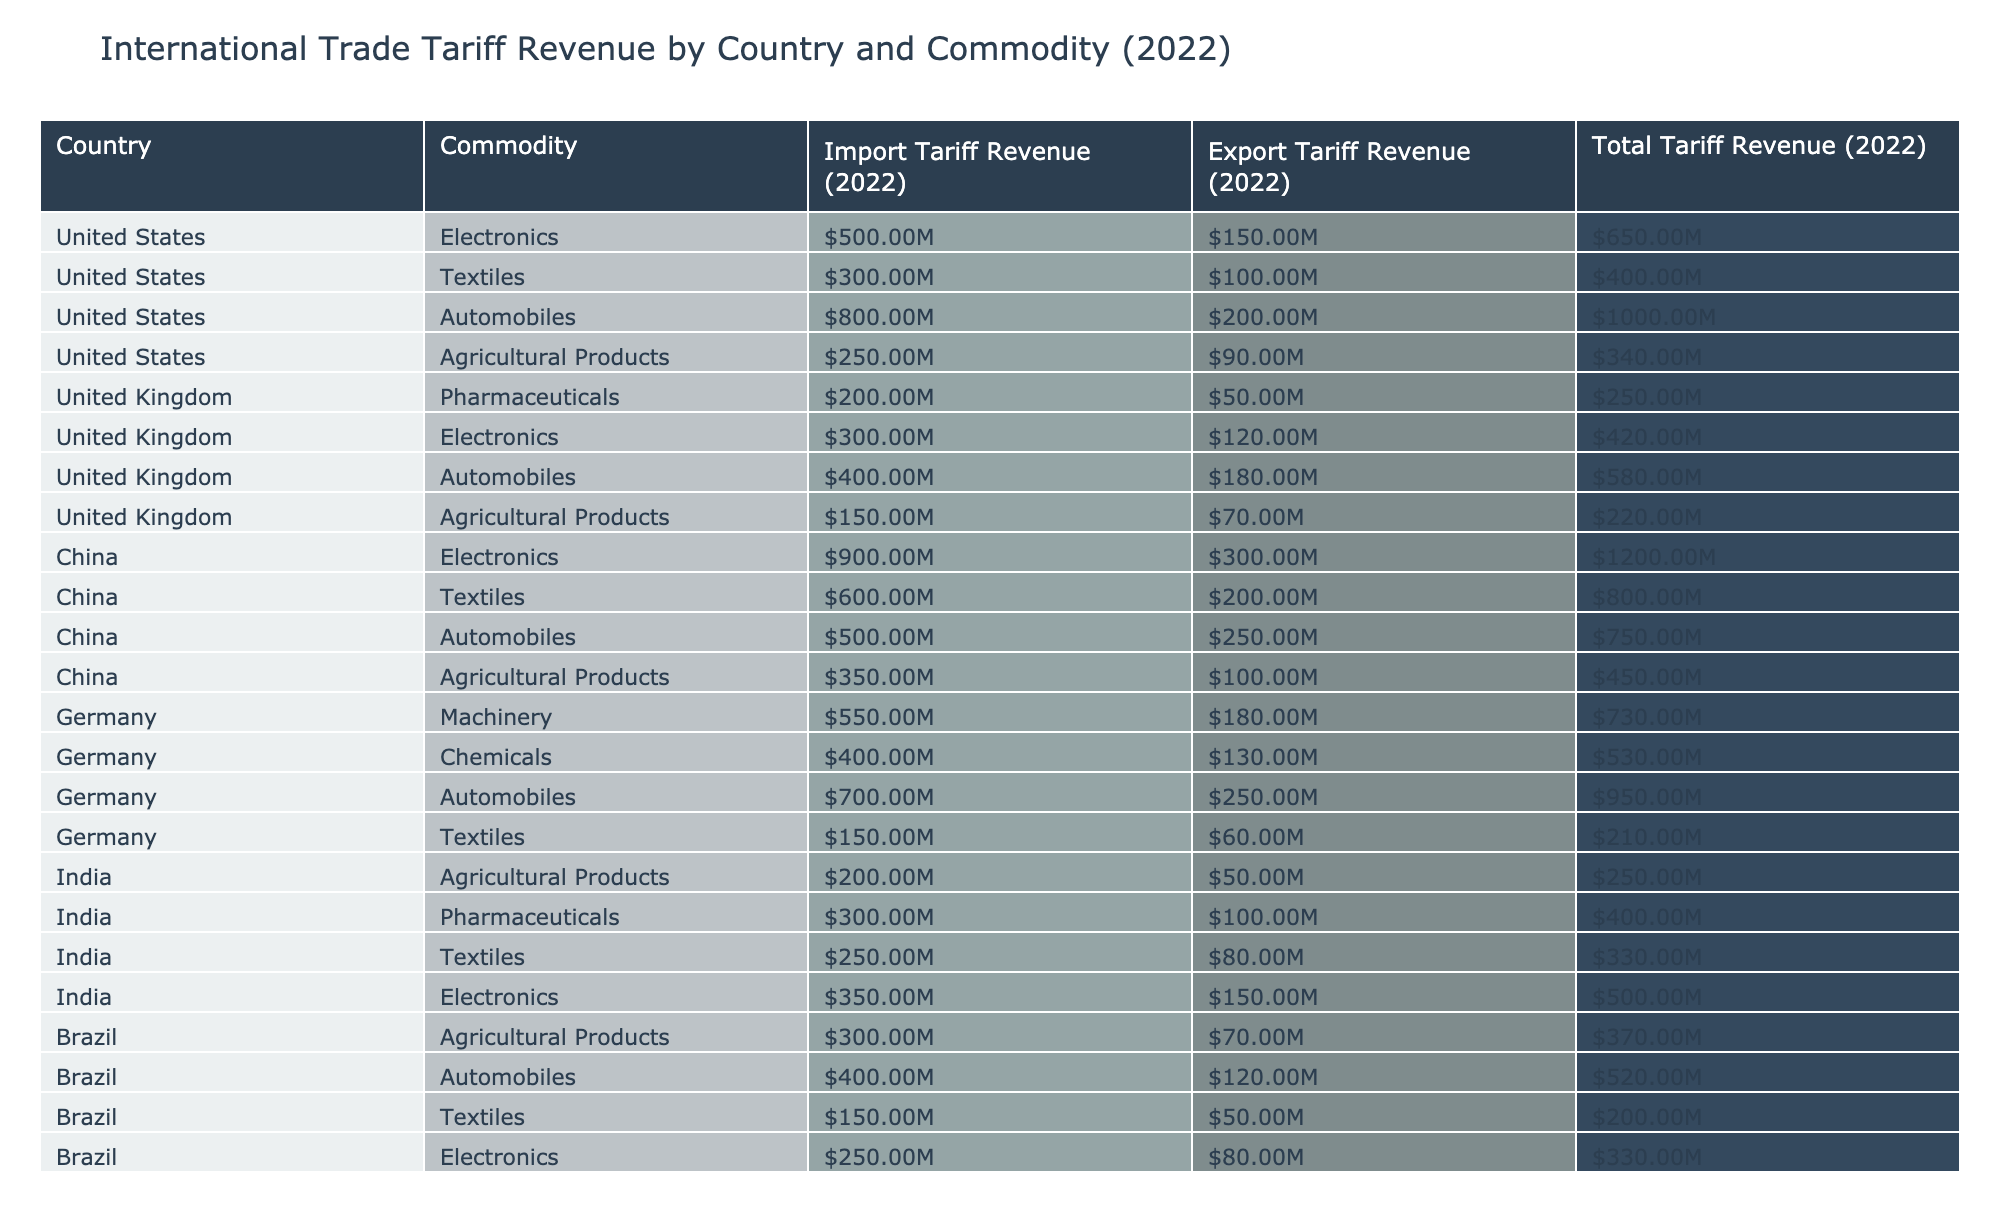What is the total tariff revenue generated from automobiles in the United States? The total tariff revenue from automobiles in the United States is specified in the table under the "Total Tariff Revenue (2022)" column for that commodity, which shows $1,000,000,000.
Answer: $1,000,000,000 Which country generated the highest tariff revenue from electronics? By comparing the "Total Tariff Revenue (2022)" for the electronics commodity across different countries in the table, China has $1,200,000,000, which is higher than any other listed country.
Answer: China What is the combined import and export tariff revenue for textiles in Germany? To find this, we add the "Import Tariff Revenue (2022)" and "Export Tariff Revenue (2022)" for textiles in Germany: $150,000,000 + $60,000,000 = $210,000,000.
Answer: $210,000,000 Is the export tariff revenue from pharmaceuticals in the United Kingdom greater than that from agricultural products? By comparing the export figures in the table, pharmaceuticals in the UK generated $50,000,000 while agricultural products generated $70,000,000, which are mentioned under their respective columns. Thus, the statement is false.
Answer: No What is the percentage that agricultural products contribute to the total tariff revenue for China? To calculate this, first, find the total tariff revenue for China, which is $800,000,000 (sum of all tariffs), and the tariff revenue for agricultural products, which is $450,000,000. The percentage is then (450,000,000 / 800,000,000) * 100 = 56.25%.
Answer: 56.25% What is the total tariff revenue for all commodities in the United States? To calculate the total, we add the "Total Tariff Revenue (2022)" values for all listed commodities in the United States: $650,000,000 + $400,000,000 + $1,000,000,000 + $340,000,000 = $2,390,000,000.
Answer: $2,390,000,000 Does Brazil have a higher import tariff revenue for automobiles compared to textiles? The import tariff revenue for automobiles in Brazil is $400,000,000, while for textiles it is $150,000,000. Since $400,000,000 is greater than $150,000,000, the statement is true.
Answer: Yes What is the difference in total tariff revenue between the automotive sectors in Germany and China? For Germany, the total tariff revenue for automobiles is $950,000,000, while for China it is $750,000,000. The difference is $950,000,000 - $750,000,000 = $200,000,000.
Answer: $200,000,000 